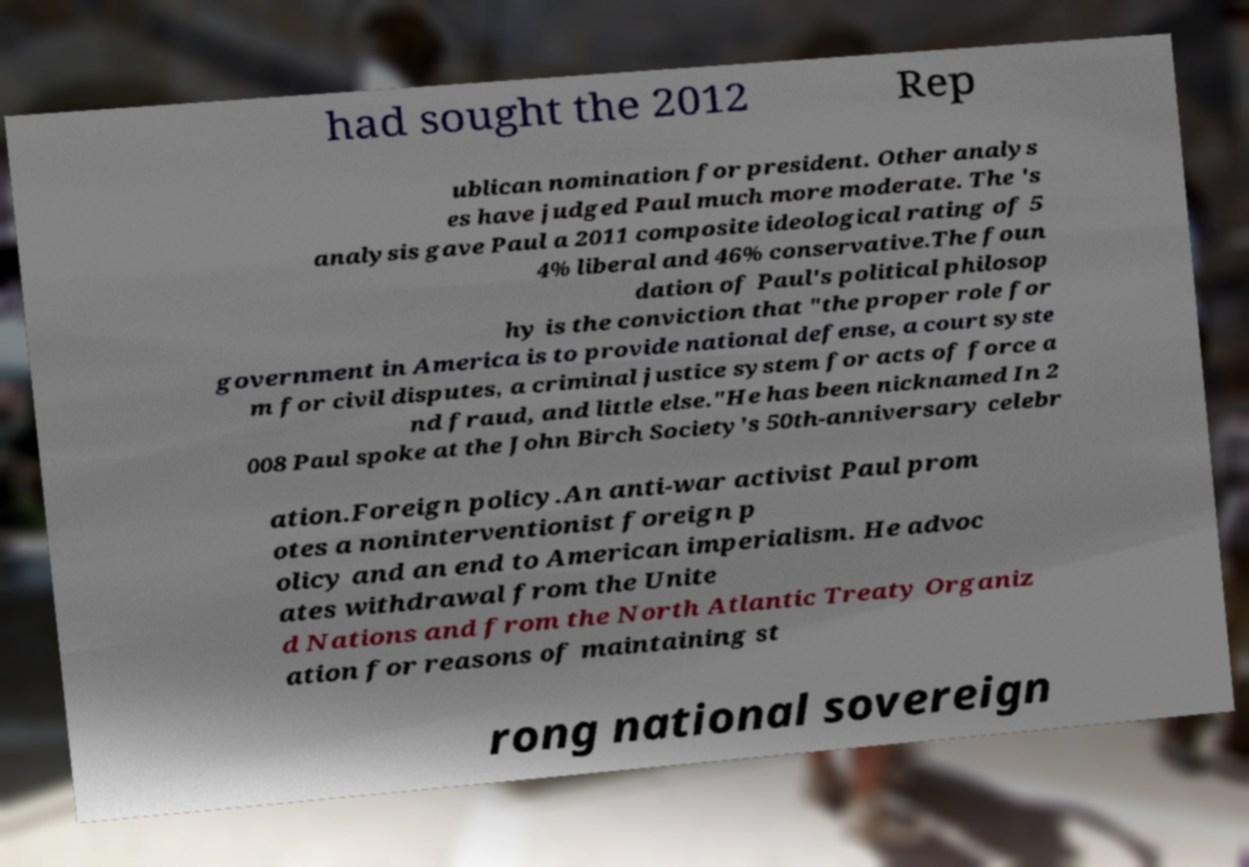Please read and relay the text visible in this image. What does it say? had sought the 2012 Rep ublican nomination for president. Other analys es have judged Paul much more moderate. The 's analysis gave Paul a 2011 composite ideological rating of 5 4% liberal and 46% conservative.The foun dation of Paul's political philosop hy is the conviction that "the proper role for government in America is to provide national defense, a court syste m for civil disputes, a criminal justice system for acts of force a nd fraud, and little else."He has been nicknamed In 2 008 Paul spoke at the John Birch Society's 50th-anniversary celebr ation.Foreign policy.An anti-war activist Paul prom otes a noninterventionist foreign p olicy and an end to American imperialism. He advoc ates withdrawal from the Unite d Nations and from the North Atlantic Treaty Organiz ation for reasons of maintaining st rong national sovereign 